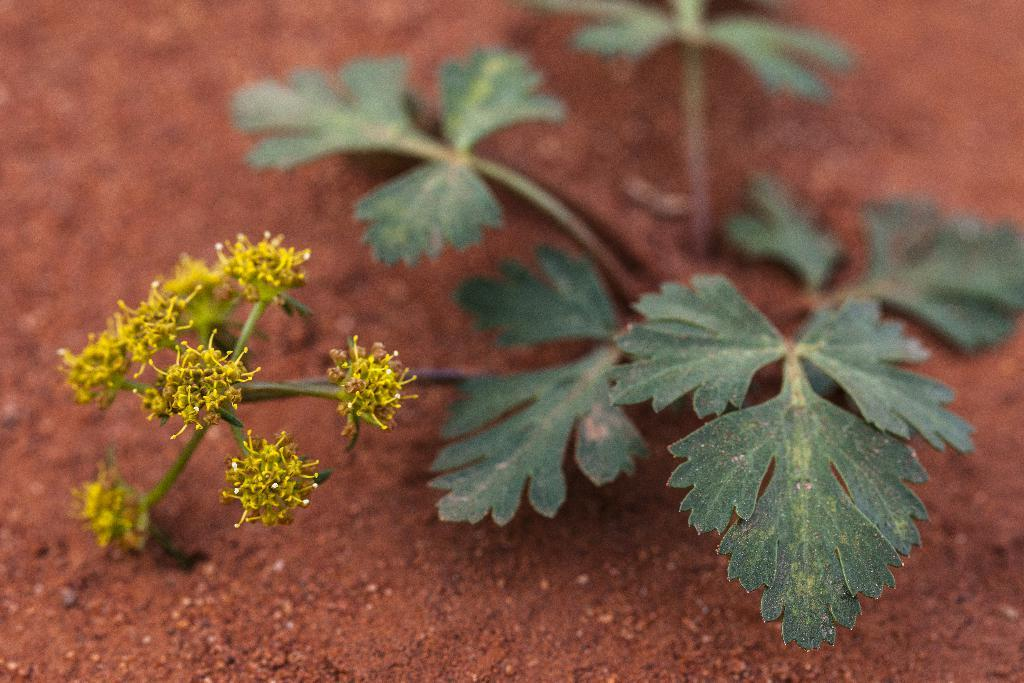What type of living organisms are present in the image? There are small plants in the image. Where are the small plants located? The small plants are on the ground. What type of pancake is being flipped in the image? There is no pancake present in the image; it only features small plants on the ground. 